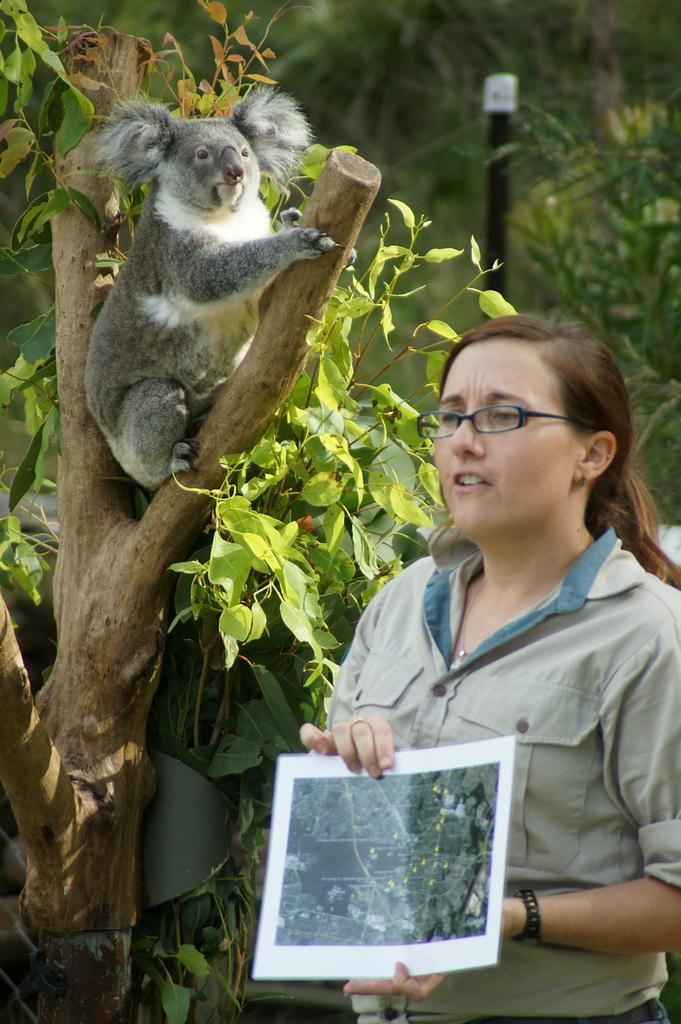Describe this image in one or two sentences. Here we can see a woman holding a paper with her hands and she has spectacles. Here we can see trees, pole, and an animal. 